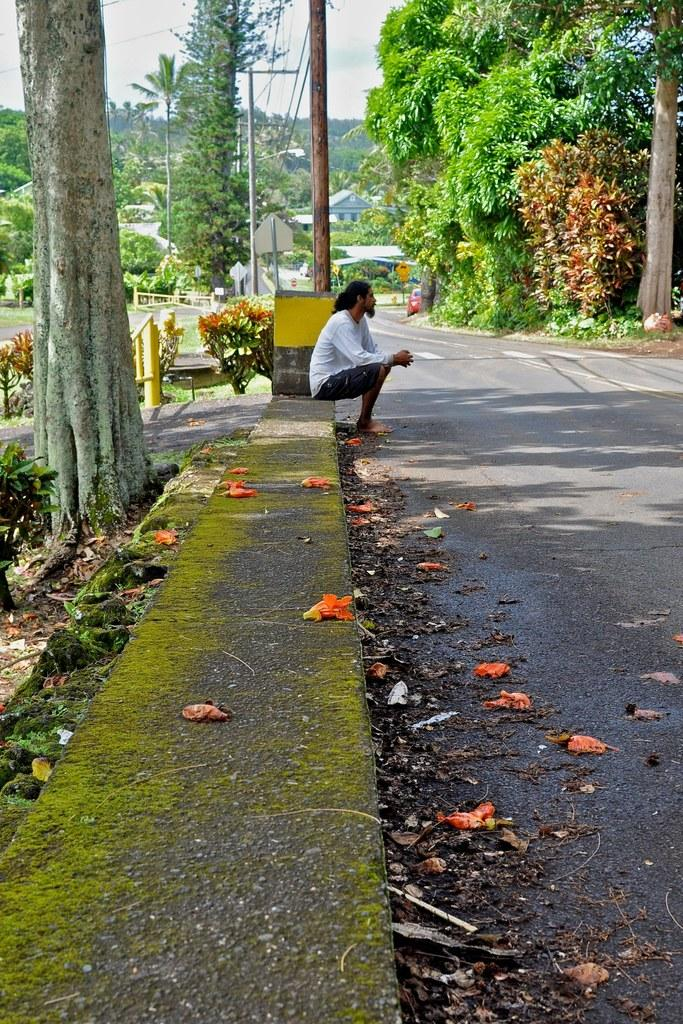What is the person in the image doing? The person is sitting on the footpath. What is located near the person? The person is beside a garden. What is in front of the person? There is a road in front of the person. What can be seen around the person? There are many trees around the person. What type of tooth is visible in the person's mouth in the image? There is no tooth visible in the person's mouth in the image. What is the person's desire while sitting on the footpath? The image does not provide any information about the person's desires or thoughts. 